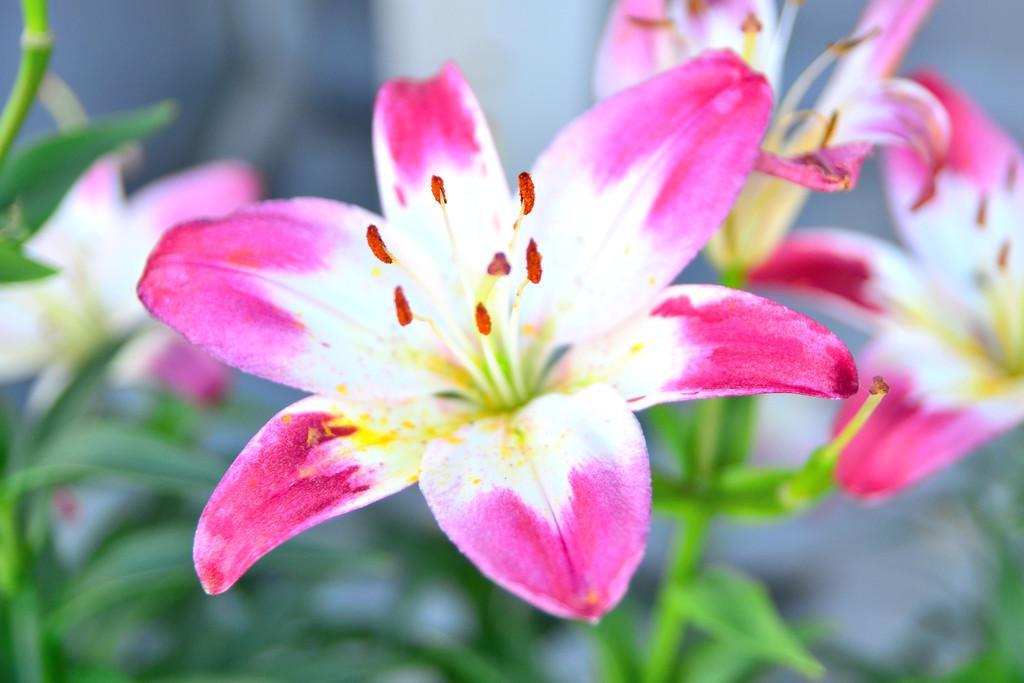Could you give a brief overview of what you see in this image? There are flowers to a plant in the foreground area of the image and the background is blurry. 